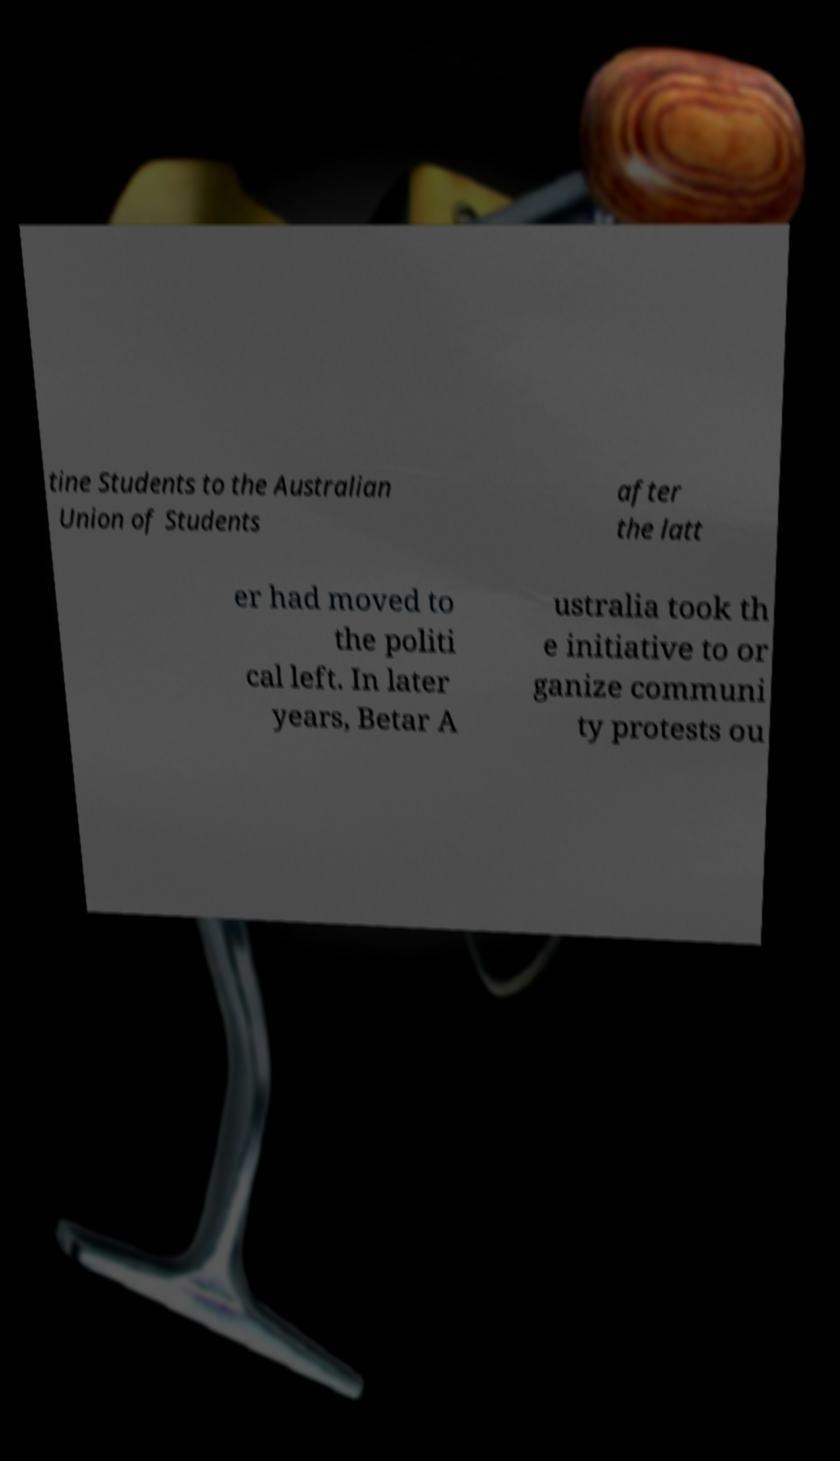Please read and relay the text visible in this image. What does it say? tine Students to the Australian Union of Students after the latt er had moved to the politi cal left. In later years, Betar A ustralia took th e initiative to or ganize communi ty protests ou 